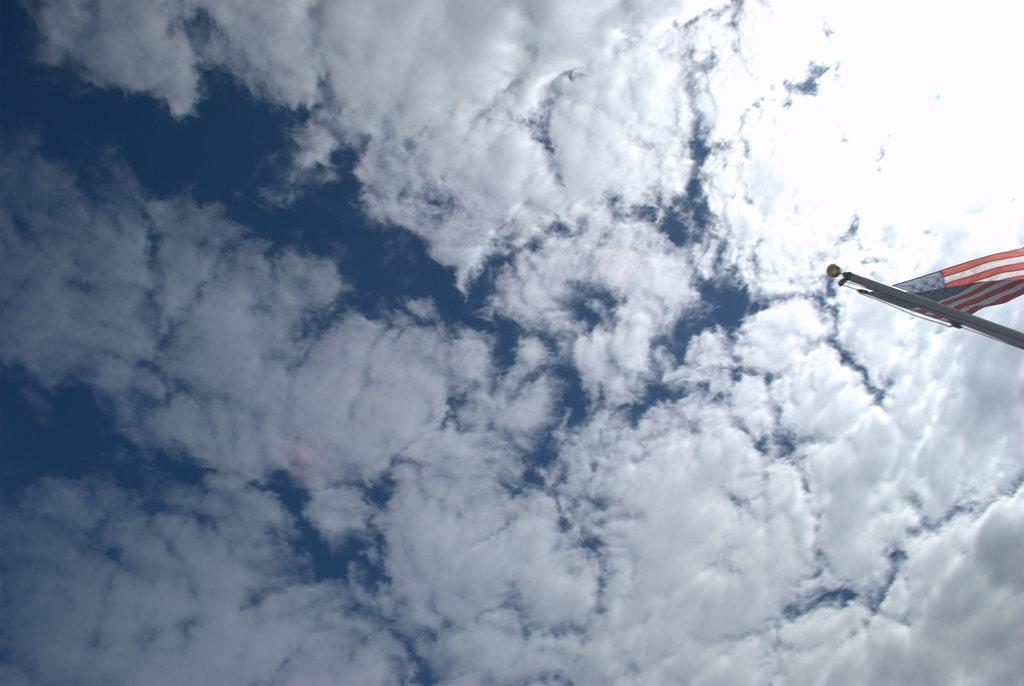Can you describe this image briefly? In this picture there is a sky with clouds. Towards the right, there is a flag to a pole. 